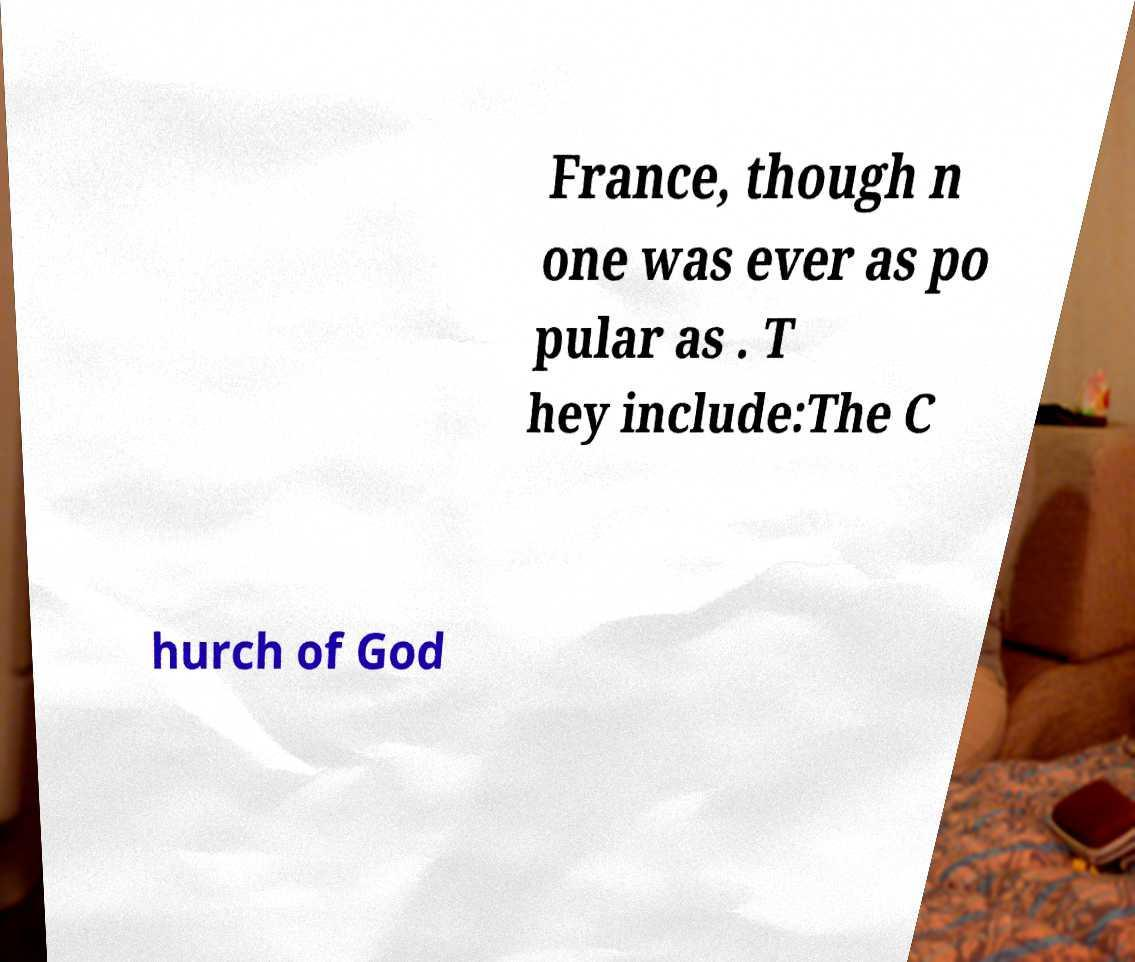Could you extract and type out the text from this image? France, though n one was ever as po pular as . T hey include:The C hurch of God 